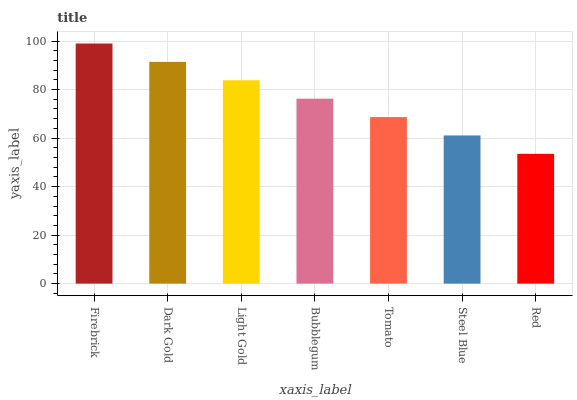Is Red the minimum?
Answer yes or no. Yes. Is Firebrick the maximum?
Answer yes or no. Yes. Is Dark Gold the minimum?
Answer yes or no. No. Is Dark Gold the maximum?
Answer yes or no. No. Is Firebrick greater than Dark Gold?
Answer yes or no. Yes. Is Dark Gold less than Firebrick?
Answer yes or no. Yes. Is Dark Gold greater than Firebrick?
Answer yes or no. No. Is Firebrick less than Dark Gold?
Answer yes or no. No. Is Bubblegum the high median?
Answer yes or no. Yes. Is Bubblegum the low median?
Answer yes or no. Yes. Is Firebrick the high median?
Answer yes or no. No. Is Tomato the low median?
Answer yes or no. No. 